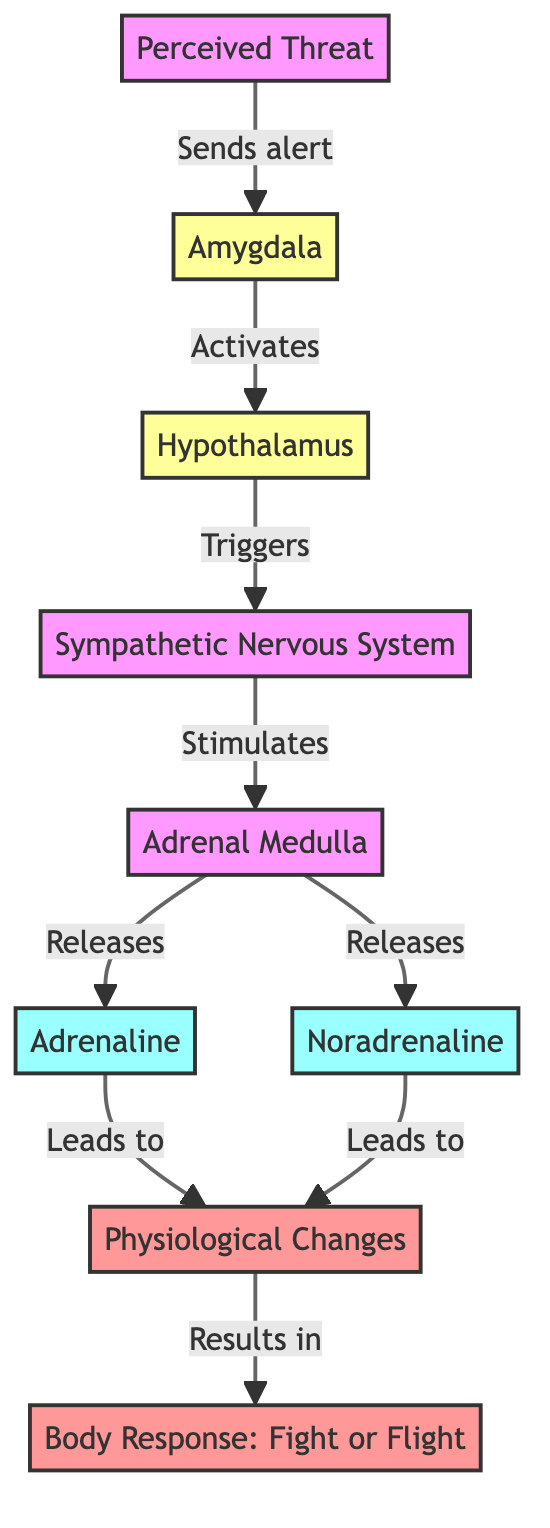What is the first node in the diagram? The first node, which initiates the response to stress, is "Perceived Threat".
Answer: Perceived Threat How many hormone nodes are present in the diagram? There are two hormone nodes in the diagram: "Adrenaline" and "Noradrenaline", totaling to two.
Answer: 2 Which node receives the alert signal from the perceived threat? The node that receives the alert signal from the perceived threat is the "Amygdala".
Answer: Amygdala What does the adrenal medulla release during the response? The adrenal medulla releases both "Adrenaline" and "Noradrenaline" during the response to stress.
Answer: Adrenaline and Noradrenaline What physiological outcome results from the combined effects of adrenaline and noradrenaline? The combined effects of adrenaline and noradrenaline lead to "Physiological Changes".
Answer: Physiological Changes What mechanism is described by the final node in the diagram? The final node describes the mechanism of "Body Response: Fight or Flight", which is the outcome of the physiological changes.
Answer: Body Response: Fight or Flight Which node connects the hypothalamus to the sympathetic nervous system? The node that connects the hypothalamus to the sympathetic nervous system is the "Trigger". This relationship is shown as "Triggers" in the diagram.
Answer: Triggers Which node corresponds to the body's direct response to stress? The node that corresponds to the body's direct response to stress is "Body Response: Fight or Flight".
Answer: Body Response: Fight or Flight What type of system is activated following the amygdala's activation? The type of system activated following the amygdala's activation is the "Sympathetic Nervous System".
Answer: Sympathetic Nervous System 